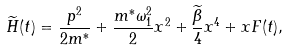<formula> <loc_0><loc_0><loc_500><loc_500>\widetilde { H } ( t ) = \frac { p ^ { 2 } } { 2 m ^ { * } } + \frac { m ^ { * } \omega _ { 1 } ^ { 2 } } { 2 } x ^ { 2 } + \frac { \widetilde { \beta } } { 4 } x ^ { 4 } + x F ( t ) ,</formula> 